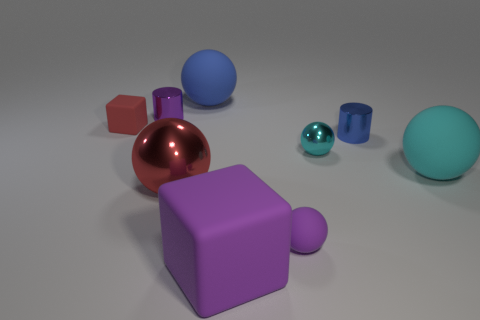There is a matte block behind the blue metallic cylinder; is its size the same as the tiny cyan metallic sphere?
Your answer should be very brief. Yes. What material is the blue cylinder that is behind the large red ball?
Offer a terse response. Metal. What number of rubber objects are either tiny purple balls or blue things?
Your answer should be compact. 2. Are there fewer small red matte things in front of the purple rubber block than green rubber cylinders?
Make the answer very short. No. The tiny purple object in front of the rubber block that is behind the block that is on the right side of the big blue matte thing is what shape?
Offer a terse response. Sphere. Is the tiny metallic sphere the same color as the tiny matte sphere?
Keep it short and to the point. No. Is the number of big purple rubber objects greater than the number of big objects?
Provide a succinct answer. No. What number of other things are made of the same material as the large purple block?
Ensure brevity in your answer.  4. What number of things are either tiny green shiny cylinders or small metallic objects that are on the left side of the big blue rubber object?
Make the answer very short. 1. Is the number of small blue matte objects less than the number of purple blocks?
Your answer should be very brief. Yes. 